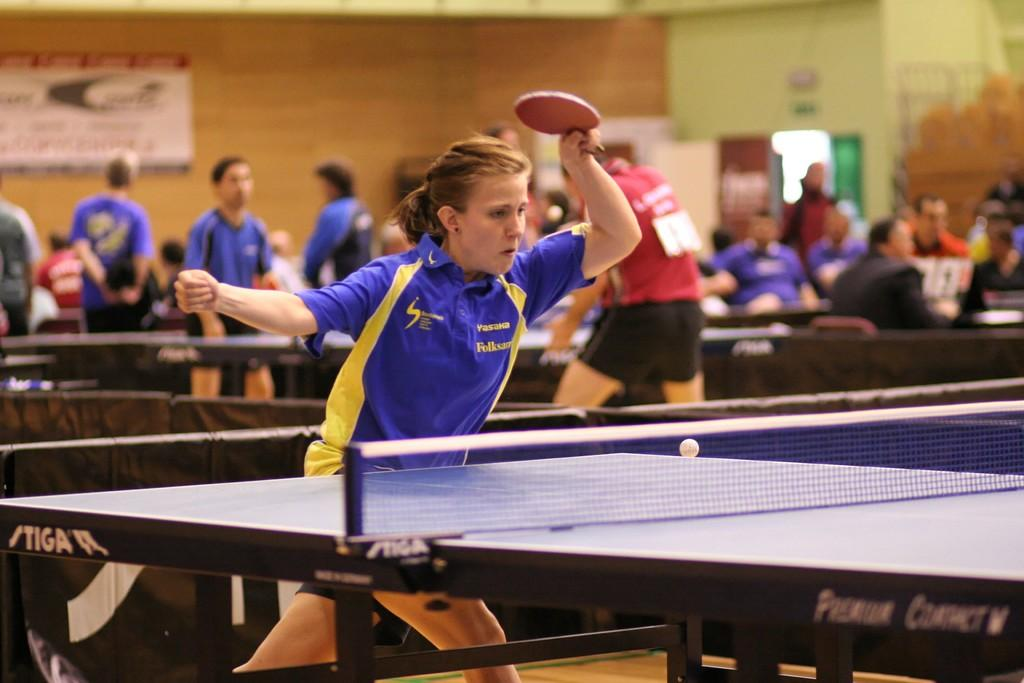Who is the main subject in the image? There is a woman in the image. What is the woman holding in the image? The woman is holding a bat. What activity is the woman engaged in? The woman is playing table tennis. Can you describe the people in the image? There are people sitting and standing in the image. What is attached to the wall in the image? There is a banner attached to a wall in the image. What type of button can be seen on the woman's shirt in the image? There is no button visible on the woman's shirt in the image. What role does the woman play in the act being performed in the image? The image does not depict an act or performance, so there is no role for the woman to play. 